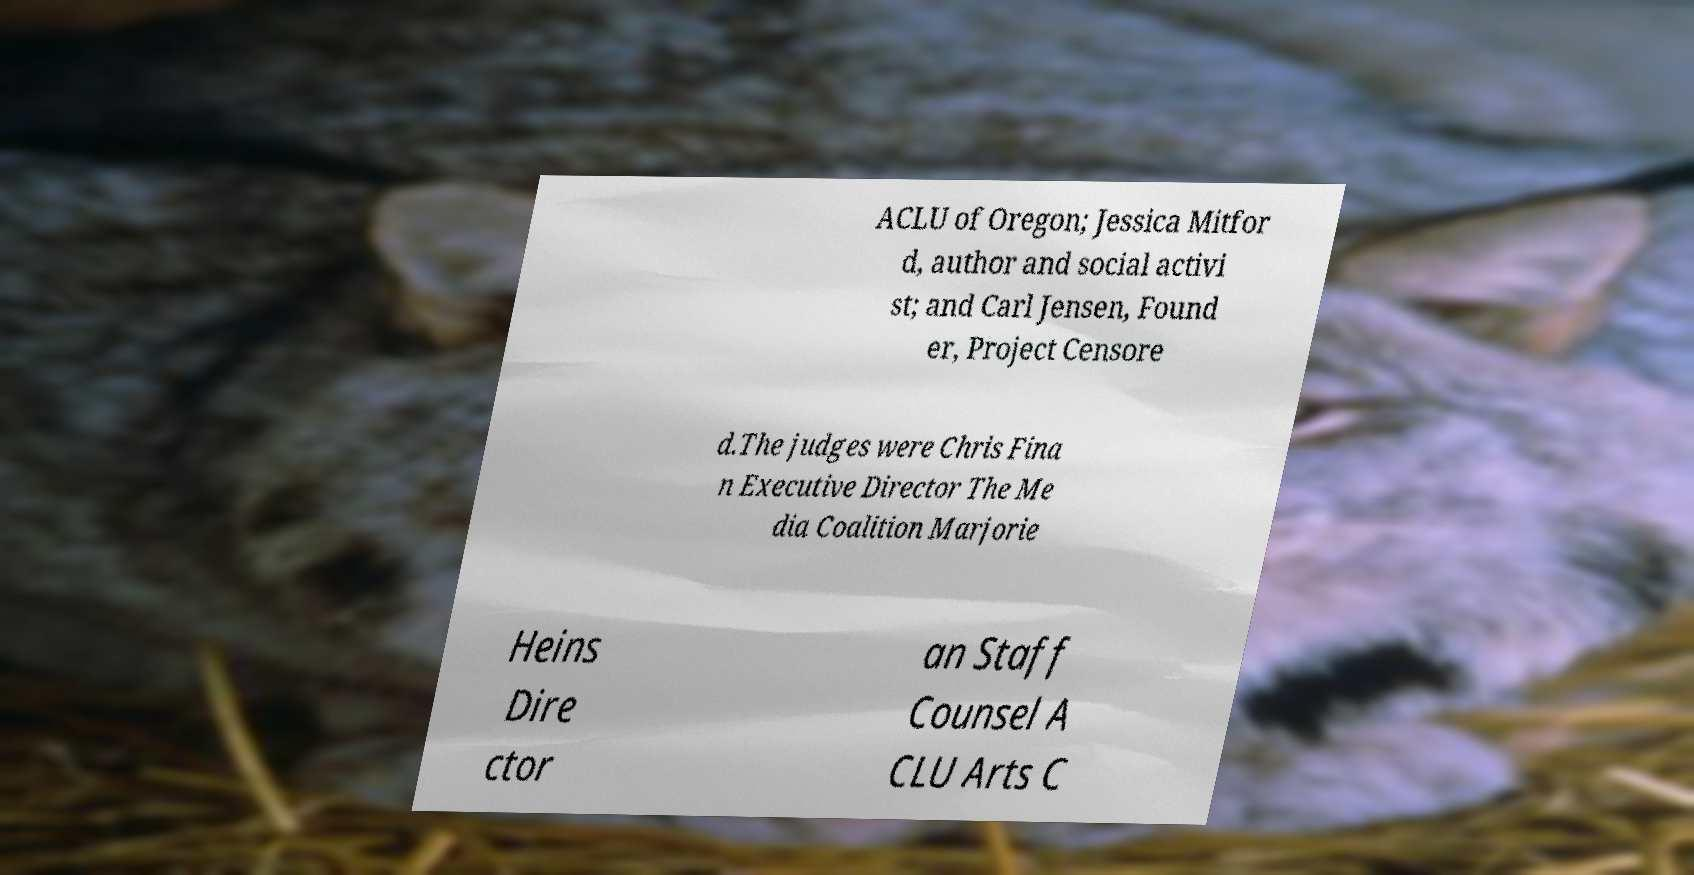Could you extract and type out the text from this image? ACLU of Oregon; Jessica Mitfor d, author and social activi st; and Carl Jensen, Found er, Project Censore d.The judges were Chris Fina n Executive Director The Me dia Coalition Marjorie Heins Dire ctor an Staff Counsel A CLU Arts C 